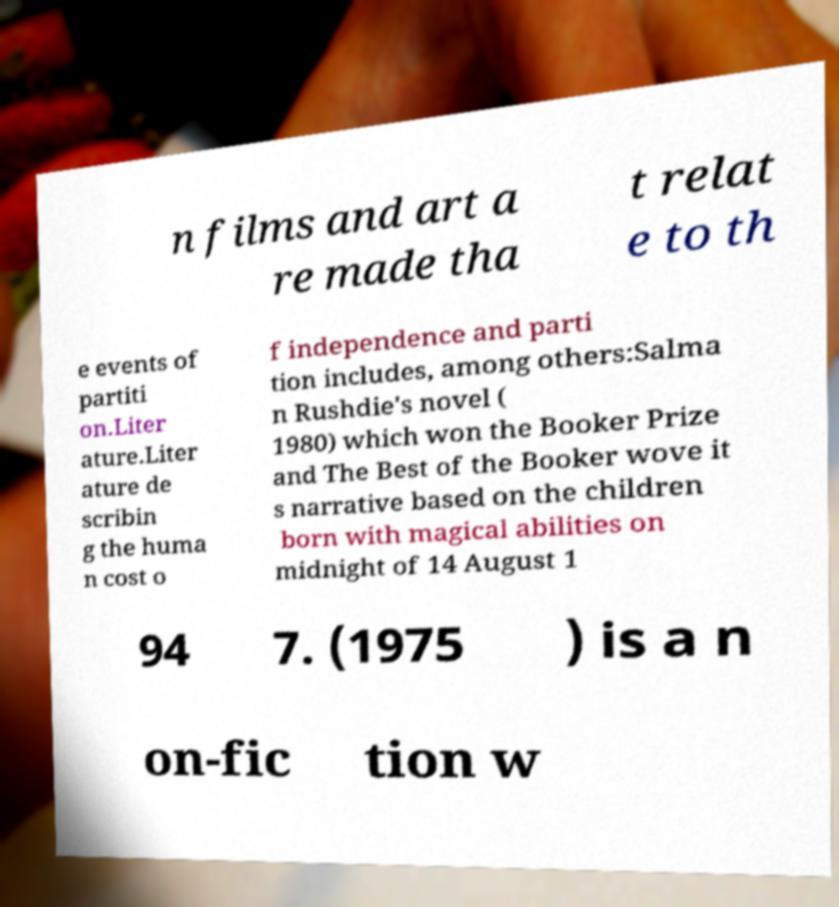Could you assist in decoding the text presented in this image and type it out clearly? n films and art a re made tha t relat e to th e events of partiti on.Liter ature.Liter ature de scribin g the huma n cost o f independence and parti tion includes, among others:Salma n Rushdie's novel ( 1980) which won the Booker Prize and The Best of the Booker wove it s narrative based on the children born with magical abilities on midnight of 14 August 1 94 7. (1975 ) is a n on-fic tion w 